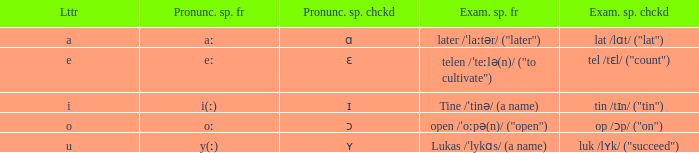What is Letter, when Example Spelled Checked is "tin /tɪn/ ("tin")"? I. 